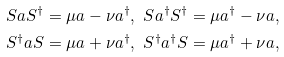Convert formula to latex. <formula><loc_0><loc_0><loc_500><loc_500>S a S ^ { \dag } & = \mu a - \nu a ^ { \dag } , \text { } S a ^ { \dag } S ^ { \dag } = \mu a ^ { \dag } - \nu a , \\ S ^ { \dag } a S & = \mu a + \nu a ^ { \dag } , \text { } S ^ { \dag } a ^ { \dag } S = \mu a ^ { \dag } + \nu a ,</formula> 